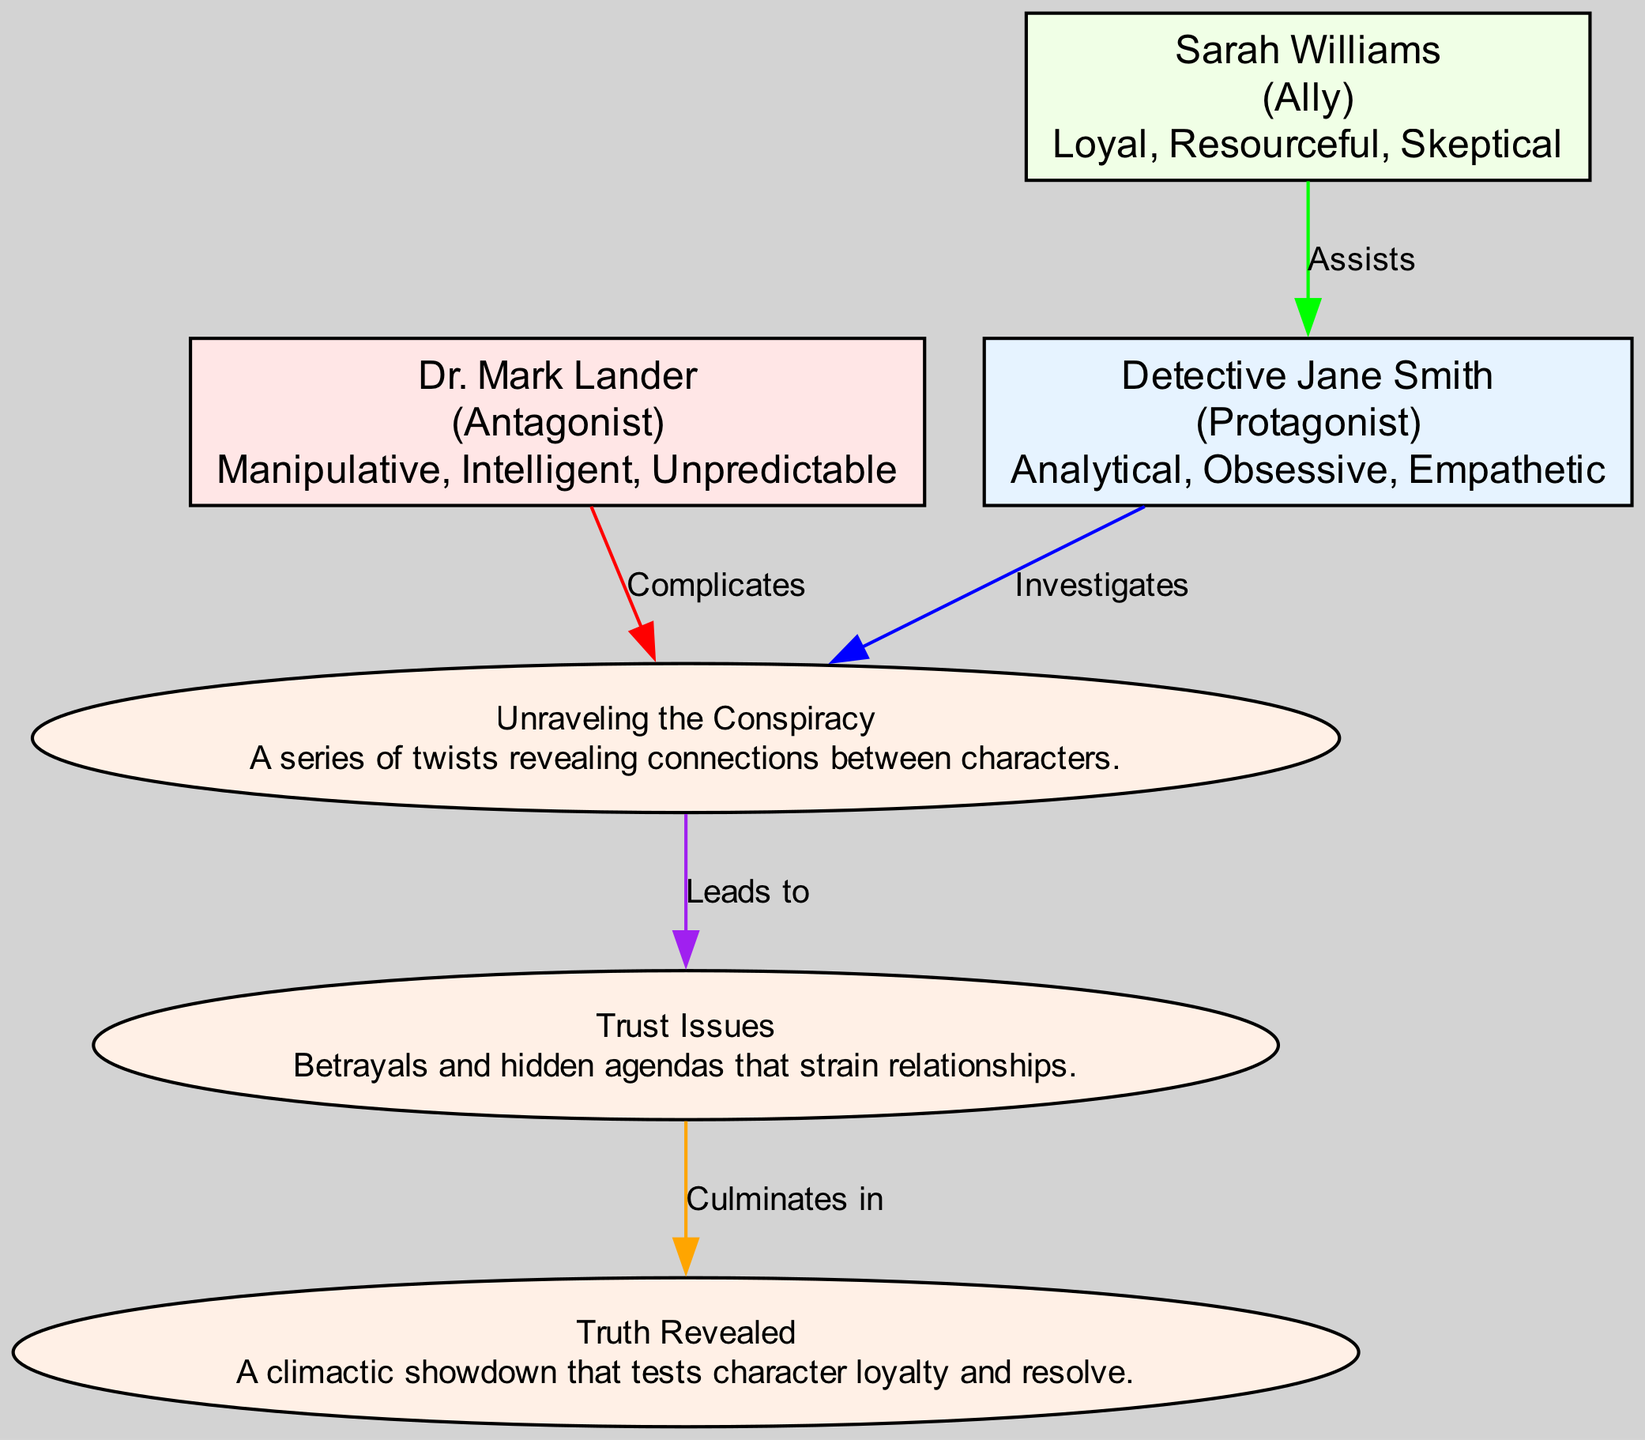What is the role of Detective Jane Smith? The diagram explicitly states that Detective Jane Smith is the Protagonist. This information is found in the node representing her character.
Answer: Protagonist How many characters are listed in the diagram? By counting the nodes labeled as characters, we identify three: Detective Jane Smith, Dr. Mark Lander, and Sarah Williams. Therefore, the total is three characters.
Answer: 3 What relationship does Dr. Mark Lander have with the Plot Arc? The diagram shows an edge from Dr. Mark Lander to the Plot Arc labeled "Complicates." This indicates that he adds complexity to the plot.
Answer: Complicates What is the main conflict depicted in the flow chart? The flow chart includes a node labeled "Trust Issues," which directly corresponds to the primary conflict faced by the characters.
Answer: Trust Issues Which character assists Detective Jane Smith in the investigation? There is an edge from Sarah Williams to Detective Jane Smith labeled "Assists," indicating that she helps the protagonist.
Answer: Sarah Williams What connection exists between the Plot Arc and the Resolution? According to the diagram, there is a direct edge from the Plot Arc to the Resolution labeled "Leads to," which indicates that the plot's developments result in the final outcome.
Answer: Leads to Which two traits are associated with Dr. Mark Lander? By examining the node for Dr. Mark Lander, we see he is described with the traits "Manipulative" and "Intelligent."
Answer: Manipulative, Intelligent What is the final outcome in the flow chart? The last node in the flow chart is labeled "Truth Revealed," representing the outcome of the narrative arc. This is the resolution of the events depicted in the diagram.
Answer: Truth Revealed How does the Conflict culminate in the Resolution? The diagram indicates that the Conflict labeled "Trust Issues" culminates in the Resolution through an edge labeled "Culminates in," suggesting that the resolution is a result of the conflicts faced.
Answer: Culminates in 